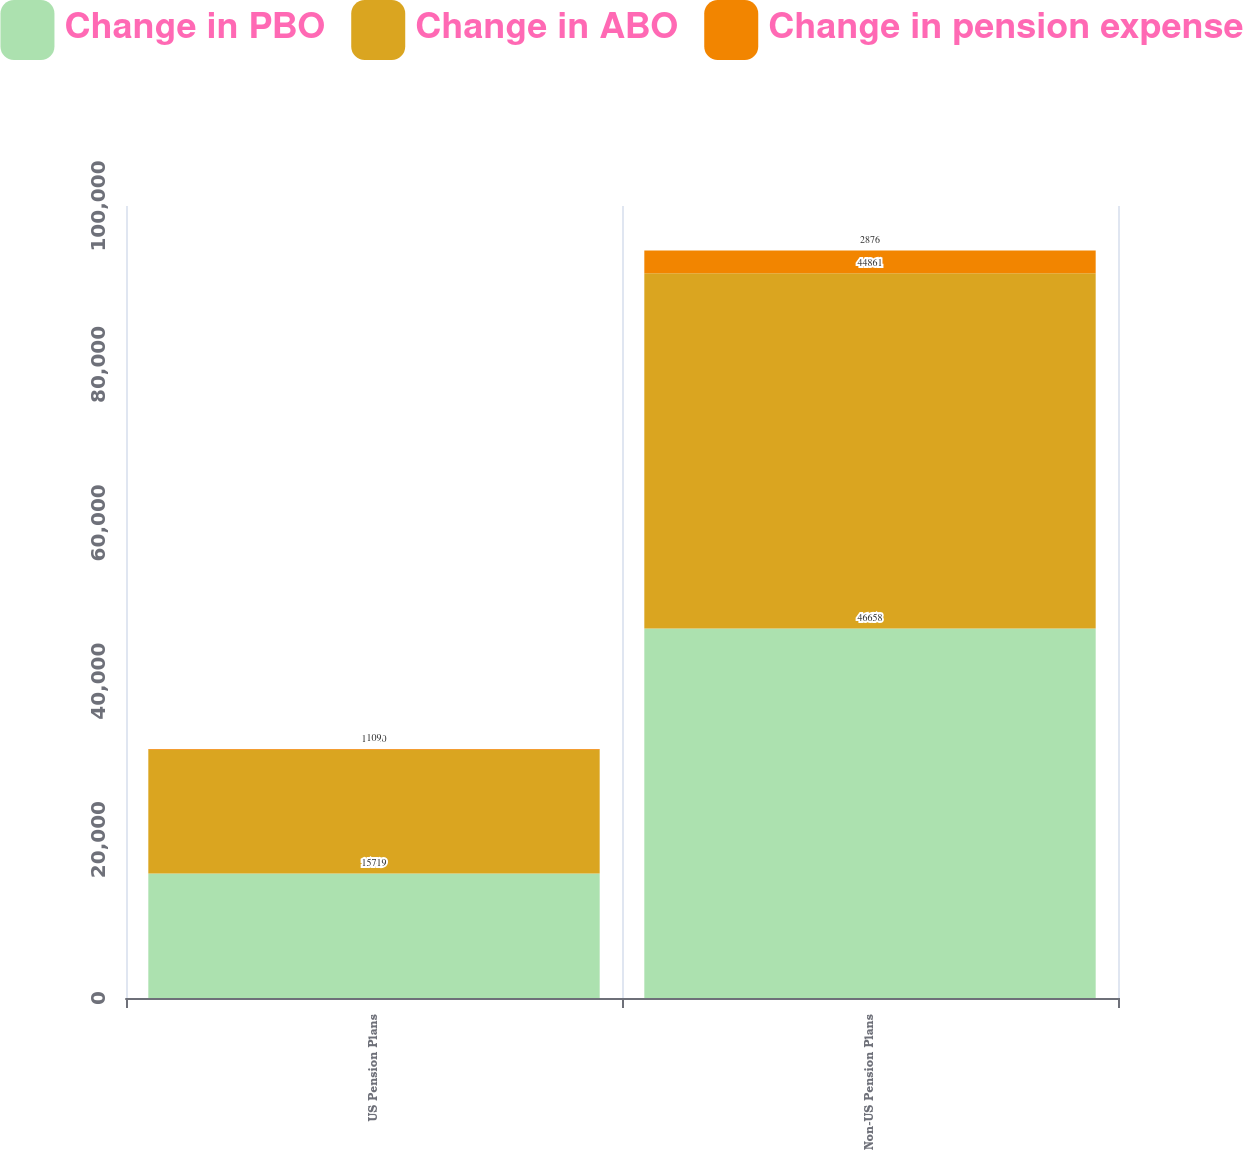<chart> <loc_0><loc_0><loc_500><loc_500><stacked_bar_chart><ecel><fcel>US Pension Plans<fcel>Non-US Pension Plans<nl><fcel>Change in PBO<fcel>15719<fcel>46658<nl><fcel>Change in ABO<fcel>15620<fcel>44861<nl><fcel>Change in pension expense<fcel>109<fcel>2876<nl></chart> 